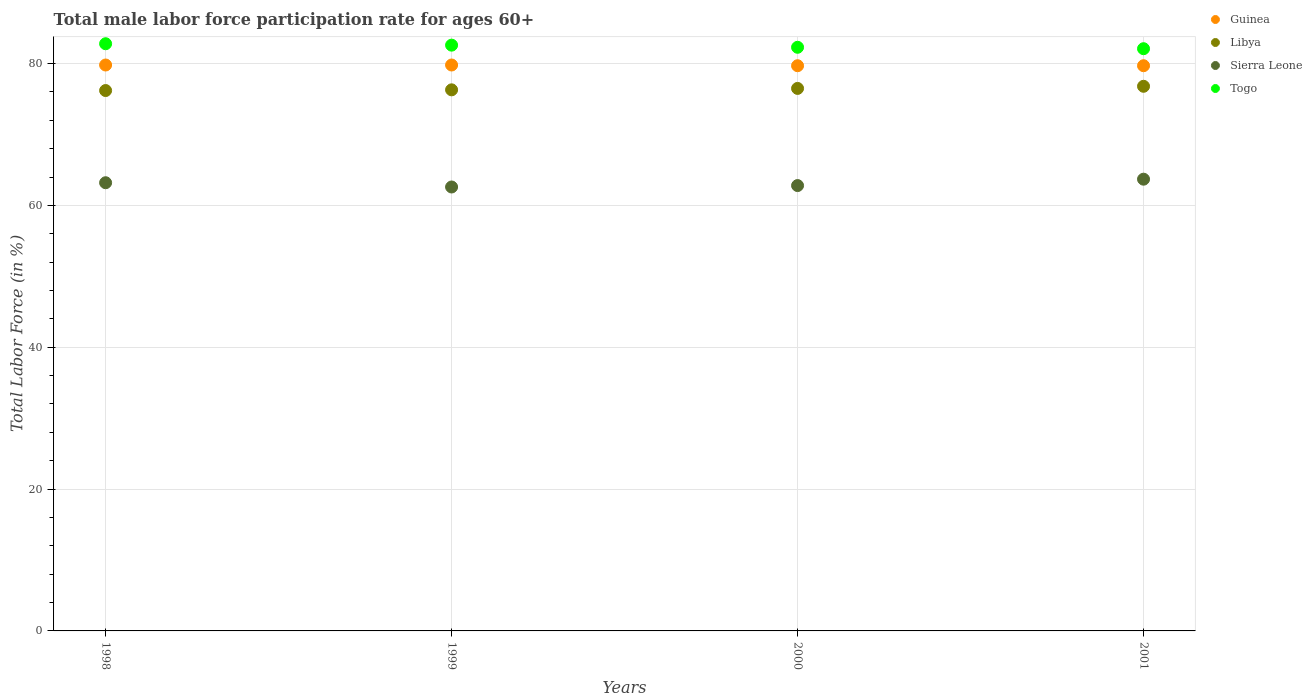What is the male labor force participation rate in Sierra Leone in 1998?
Your answer should be very brief. 63.2. Across all years, what is the maximum male labor force participation rate in Libya?
Your answer should be compact. 76.8. Across all years, what is the minimum male labor force participation rate in Togo?
Give a very brief answer. 82.1. In which year was the male labor force participation rate in Sierra Leone maximum?
Your answer should be compact. 2001. What is the total male labor force participation rate in Guinea in the graph?
Keep it short and to the point. 319. What is the difference between the male labor force participation rate in Togo in 1998 and that in 1999?
Give a very brief answer. 0.2. What is the difference between the male labor force participation rate in Libya in 1998 and the male labor force participation rate in Sierra Leone in 1999?
Offer a very short reply. 13.6. What is the average male labor force participation rate in Sierra Leone per year?
Give a very brief answer. 63.07. In the year 2001, what is the difference between the male labor force participation rate in Togo and male labor force participation rate in Libya?
Your answer should be very brief. 5.3. What is the ratio of the male labor force participation rate in Sierra Leone in 1999 to that in 2000?
Your answer should be compact. 1. Is the male labor force participation rate in Guinea in 1999 less than that in 2001?
Offer a terse response. No. Is the difference between the male labor force participation rate in Togo in 1998 and 2000 greater than the difference between the male labor force participation rate in Libya in 1998 and 2000?
Keep it short and to the point. Yes. What is the difference between the highest and the second highest male labor force participation rate in Guinea?
Your answer should be very brief. 0. What is the difference between the highest and the lowest male labor force participation rate in Libya?
Offer a terse response. 0.6. In how many years, is the male labor force participation rate in Libya greater than the average male labor force participation rate in Libya taken over all years?
Keep it short and to the point. 2. Is the sum of the male labor force participation rate in Guinea in 1998 and 2000 greater than the maximum male labor force participation rate in Libya across all years?
Offer a very short reply. Yes. Is it the case that in every year, the sum of the male labor force participation rate in Sierra Leone and male labor force participation rate in Togo  is greater than the male labor force participation rate in Guinea?
Offer a terse response. Yes. Is the male labor force participation rate in Libya strictly greater than the male labor force participation rate in Sierra Leone over the years?
Your response must be concise. Yes. Is the male labor force participation rate in Sierra Leone strictly less than the male labor force participation rate in Libya over the years?
Ensure brevity in your answer.  Yes. How many dotlines are there?
Give a very brief answer. 4. Does the graph contain grids?
Make the answer very short. Yes. Where does the legend appear in the graph?
Provide a short and direct response. Top right. How are the legend labels stacked?
Your response must be concise. Vertical. What is the title of the graph?
Keep it short and to the point. Total male labor force participation rate for ages 60+. What is the label or title of the X-axis?
Offer a very short reply. Years. What is the label or title of the Y-axis?
Offer a terse response. Total Labor Force (in %). What is the Total Labor Force (in %) of Guinea in 1998?
Your response must be concise. 79.8. What is the Total Labor Force (in %) in Libya in 1998?
Make the answer very short. 76.2. What is the Total Labor Force (in %) in Sierra Leone in 1998?
Provide a succinct answer. 63.2. What is the Total Labor Force (in %) of Togo in 1998?
Your answer should be very brief. 82.8. What is the Total Labor Force (in %) of Guinea in 1999?
Keep it short and to the point. 79.8. What is the Total Labor Force (in %) in Libya in 1999?
Your answer should be very brief. 76.3. What is the Total Labor Force (in %) in Sierra Leone in 1999?
Your response must be concise. 62.6. What is the Total Labor Force (in %) in Togo in 1999?
Your response must be concise. 82.6. What is the Total Labor Force (in %) in Guinea in 2000?
Keep it short and to the point. 79.7. What is the Total Labor Force (in %) of Libya in 2000?
Ensure brevity in your answer.  76.5. What is the Total Labor Force (in %) in Sierra Leone in 2000?
Keep it short and to the point. 62.8. What is the Total Labor Force (in %) in Togo in 2000?
Make the answer very short. 82.3. What is the Total Labor Force (in %) in Guinea in 2001?
Ensure brevity in your answer.  79.7. What is the Total Labor Force (in %) of Libya in 2001?
Make the answer very short. 76.8. What is the Total Labor Force (in %) in Sierra Leone in 2001?
Keep it short and to the point. 63.7. What is the Total Labor Force (in %) in Togo in 2001?
Make the answer very short. 82.1. Across all years, what is the maximum Total Labor Force (in %) of Guinea?
Ensure brevity in your answer.  79.8. Across all years, what is the maximum Total Labor Force (in %) of Libya?
Offer a very short reply. 76.8. Across all years, what is the maximum Total Labor Force (in %) of Sierra Leone?
Your answer should be very brief. 63.7. Across all years, what is the maximum Total Labor Force (in %) in Togo?
Provide a succinct answer. 82.8. Across all years, what is the minimum Total Labor Force (in %) of Guinea?
Give a very brief answer. 79.7. Across all years, what is the minimum Total Labor Force (in %) in Libya?
Make the answer very short. 76.2. Across all years, what is the minimum Total Labor Force (in %) of Sierra Leone?
Your answer should be compact. 62.6. Across all years, what is the minimum Total Labor Force (in %) in Togo?
Offer a very short reply. 82.1. What is the total Total Labor Force (in %) in Guinea in the graph?
Your response must be concise. 319. What is the total Total Labor Force (in %) in Libya in the graph?
Give a very brief answer. 305.8. What is the total Total Labor Force (in %) in Sierra Leone in the graph?
Your answer should be very brief. 252.3. What is the total Total Labor Force (in %) of Togo in the graph?
Your answer should be very brief. 329.8. What is the difference between the Total Labor Force (in %) in Libya in 1998 and that in 1999?
Your answer should be compact. -0.1. What is the difference between the Total Labor Force (in %) of Sierra Leone in 1998 and that in 1999?
Provide a succinct answer. 0.6. What is the difference between the Total Labor Force (in %) of Guinea in 1998 and that in 2001?
Your response must be concise. 0.1. What is the difference between the Total Labor Force (in %) in Guinea in 1999 and that in 2001?
Keep it short and to the point. 0.1. What is the difference between the Total Labor Force (in %) of Libya in 1999 and that in 2001?
Your response must be concise. -0.5. What is the difference between the Total Labor Force (in %) in Togo in 1999 and that in 2001?
Offer a terse response. 0.5. What is the difference between the Total Labor Force (in %) of Sierra Leone in 2000 and that in 2001?
Your answer should be compact. -0.9. What is the difference between the Total Labor Force (in %) in Guinea in 1998 and the Total Labor Force (in %) in Sierra Leone in 1999?
Your answer should be very brief. 17.2. What is the difference between the Total Labor Force (in %) in Guinea in 1998 and the Total Labor Force (in %) in Togo in 1999?
Keep it short and to the point. -2.8. What is the difference between the Total Labor Force (in %) of Libya in 1998 and the Total Labor Force (in %) of Sierra Leone in 1999?
Your answer should be very brief. 13.6. What is the difference between the Total Labor Force (in %) of Sierra Leone in 1998 and the Total Labor Force (in %) of Togo in 1999?
Keep it short and to the point. -19.4. What is the difference between the Total Labor Force (in %) in Libya in 1998 and the Total Labor Force (in %) in Sierra Leone in 2000?
Give a very brief answer. 13.4. What is the difference between the Total Labor Force (in %) of Libya in 1998 and the Total Labor Force (in %) of Togo in 2000?
Make the answer very short. -6.1. What is the difference between the Total Labor Force (in %) of Sierra Leone in 1998 and the Total Labor Force (in %) of Togo in 2000?
Make the answer very short. -19.1. What is the difference between the Total Labor Force (in %) of Guinea in 1998 and the Total Labor Force (in %) of Libya in 2001?
Offer a terse response. 3. What is the difference between the Total Labor Force (in %) of Guinea in 1998 and the Total Labor Force (in %) of Togo in 2001?
Give a very brief answer. -2.3. What is the difference between the Total Labor Force (in %) in Sierra Leone in 1998 and the Total Labor Force (in %) in Togo in 2001?
Ensure brevity in your answer.  -18.9. What is the difference between the Total Labor Force (in %) in Guinea in 1999 and the Total Labor Force (in %) in Sierra Leone in 2000?
Offer a terse response. 17. What is the difference between the Total Labor Force (in %) of Guinea in 1999 and the Total Labor Force (in %) of Togo in 2000?
Provide a short and direct response. -2.5. What is the difference between the Total Labor Force (in %) in Libya in 1999 and the Total Labor Force (in %) in Sierra Leone in 2000?
Make the answer very short. 13.5. What is the difference between the Total Labor Force (in %) in Libya in 1999 and the Total Labor Force (in %) in Togo in 2000?
Offer a very short reply. -6. What is the difference between the Total Labor Force (in %) of Sierra Leone in 1999 and the Total Labor Force (in %) of Togo in 2000?
Keep it short and to the point. -19.7. What is the difference between the Total Labor Force (in %) in Guinea in 1999 and the Total Labor Force (in %) in Libya in 2001?
Offer a terse response. 3. What is the difference between the Total Labor Force (in %) of Guinea in 1999 and the Total Labor Force (in %) of Togo in 2001?
Keep it short and to the point. -2.3. What is the difference between the Total Labor Force (in %) of Libya in 1999 and the Total Labor Force (in %) of Sierra Leone in 2001?
Your answer should be compact. 12.6. What is the difference between the Total Labor Force (in %) of Libya in 1999 and the Total Labor Force (in %) of Togo in 2001?
Provide a short and direct response. -5.8. What is the difference between the Total Labor Force (in %) of Sierra Leone in 1999 and the Total Labor Force (in %) of Togo in 2001?
Your answer should be compact. -19.5. What is the difference between the Total Labor Force (in %) of Guinea in 2000 and the Total Labor Force (in %) of Libya in 2001?
Provide a short and direct response. 2.9. What is the difference between the Total Labor Force (in %) in Libya in 2000 and the Total Labor Force (in %) in Sierra Leone in 2001?
Keep it short and to the point. 12.8. What is the difference between the Total Labor Force (in %) in Libya in 2000 and the Total Labor Force (in %) in Togo in 2001?
Your answer should be very brief. -5.6. What is the difference between the Total Labor Force (in %) of Sierra Leone in 2000 and the Total Labor Force (in %) of Togo in 2001?
Offer a very short reply. -19.3. What is the average Total Labor Force (in %) in Guinea per year?
Provide a succinct answer. 79.75. What is the average Total Labor Force (in %) of Libya per year?
Provide a short and direct response. 76.45. What is the average Total Labor Force (in %) of Sierra Leone per year?
Offer a terse response. 63.08. What is the average Total Labor Force (in %) of Togo per year?
Offer a very short reply. 82.45. In the year 1998, what is the difference between the Total Labor Force (in %) of Guinea and Total Labor Force (in %) of Libya?
Your answer should be compact. 3.6. In the year 1998, what is the difference between the Total Labor Force (in %) of Guinea and Total Labor Force (in %) of Sierra Leone?
Give a very brief answer. 16.6. In the year 1998, what is the difference between the Total Labor Force (in %) in Guinea and Total Labor Force (in %) in Togo?
Offer a very short reply. -3. In the year 1998, what is the difference between the Total Labor Force (in %) in Libya and Total Labor Force (in %) in Sierra Leone?
Your answer should be compact. 13. In the year 1998, what is the difference between the Total Labor Force (in %) of Libya and Total Labor Force (in %) of Togo?
Your answer should be compact. -6.6. In the year 1998, what is the difference between the Total Labor Force (in %) in Sierra Leone and Total Labor Force (in %) in Togo?
Your answer should be compact. -19.6. In the year 1999, what is the difference between the Total Labor Force (in %) in Libya and Total Labor Force (in %) in Sierra Leone?
Offer a very short reply. 13.7. In the year 2000, what is the difference between the Total Labor Force (in %) of Guinea and Total Labor Force (in %) of Sierra Leone?
Give a very brief answer. 16.9. In the year 2000, what is the difference between the Total Labor Force (in %) of Guinea and Total Labor Force (in %) of Togo?
Ensure brevity in your answer.  -2.6. In the year 2000, what is the difference between the Total Labor Force (in %) of Libya and Total Labor Force (in %) of Sierra Leone?
Give a very brief answer. 13.7. In the year 2000, what is the difference between the Total Labor Force (in %) in Libya and Total Labor Force (in %) in Togo?
Offer a terse response. -5.8. In the year 2000, what is the difference between the Total Labor Force (in %) of Sierra Leone and Total Labor Force (in %) of Togo?
Offer a very short reply. -19.5. In the year 2001, what is the difference between the Total Labor Force (in %) in Guinea and Total Labor Force (in %) in Sierra Leone?
Provide a succinct answer. 16. In the year 2001, what is the difference between the Total Labor Force (in %) of Guinea and Total Labor Force (in %) of Togo?
Give a very brief answer. -2.4. In the year 2001, what is the difference between the Total Labor Force (in %) of Libya and Total Labor Force (in %) of Sierra Leone?
Your response must be concise. 13.1. In the year 2001, what is the difference between the Total Labor Force (in %) of Sierra Leone and Total Labor Force (in %) of Togo?
Keep it short and to the point. -18.4. What is the ratio of the Total Labor Force (in %) in Sierra Leone in 1998 to that in 1999?
Your response must be concise. 1.01. What is the ratio of the Total Labor Force (in %) in Guinea in 1998 to that in 2000?
Offer a very short reply. 1. What is the ratio of the Total Labor Force (in %) in Sierra Leone in 1998 to that in 2000?
Make the answer very short. 1.01. What is the ratio of the Total Labor Force (in %) in Togo in 1998 to that in 2000?
Ensure brevity in your answer.  1.01. What is the ratio of the Total Labor Force (in %) of Togo in 1998 to that in 2001?
Keep it short and to the point. 1.01. What is the ratio of the Total Labor Force (in %) in Sierra Leone in 1999 to that in 2000?
Your answer should be very brief. 1. What is the ratio of the Total Labor Force (in %) of Togo in 1999 to that in 2000?
Your answer should be compact. 1. What is the ratio of the Total Labor Force (in %) in Guinea in 1999 to that in 2001?
Your response must be concise. 1. What is the ratio of the Total Labor Force (in %) of Sierra Leone in 1999 to that in 2001?
Provide a succinct answer. 0.98. What is the ratio of the Total Labor Force (in %) in Sierra Leone in 2000 to that in 2001?
Provide a short and direct response. 0.99. What is the difference between the highest and the second highest Total Labor Force (in %) in Guinea?
Offer a terse response. 0. What is the difference between the highest and the second highest Total Labor Force (in %) of Libya?
Provide a short and direct response. 0.3. What is the difference between the highest and the second highest Total Labor Force (in %) in Togo?
Ensure brevity in your answer.  0.2. 